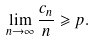Convert formula to latex. <formula><loc_0><loc_0><loc_500><loc_500>\lim _ { n \to \infty } \frac { c _ { n } } { n } \geqslant p .</formula> 